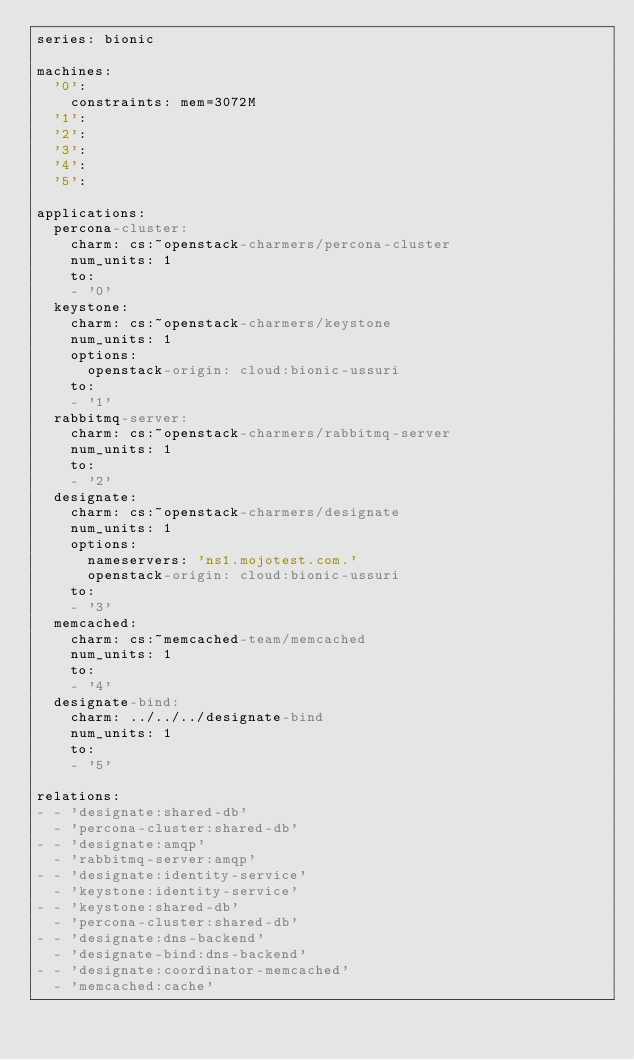Convert code to text. <code><loc_0><loc_0><loc_500><loc_500><_YAML_>series: bionic

machines:
  '0':
    constraints: mem=3072M
  '1':
  '2':
  '3':
  '4':
  '5':

applications:
  percona-cluster:
    charm: cs:~openstack-charmers/percona-cluster
    num_units: 1
    to:
    - '0'
  keystone:
    charm: cs:~openstack-charmers/keystone
    num_units: 1
    options:
      openstack-origin: cloud:bionic-ussuri
    to:
    - '1'
  rabbitmq-server:
    charm: cs:~openstack-charmers/rabbitmq-server
    num_units: 1
    to:
    - '2'
  designate:
    charm: cs:~openstack-charmers/designate
    num_units: 1
    options:
      nameservers: 'ns1.mojotest.com.'
      openstack-origin: cloud:bionic-ussuri
    to:
    - '3'
  memcached:
    charm: cs:~memcached-team/memcached
    num_units: 1
    to:
    - '4'
  designate-bind:
    charm: ../../../designate-bind
    num_units: 1
    to:
    - '5'

relations:
- - 'designate:shared-db'
  - 'percona-cluster:shared-db'
- - 'designate:amqp'
  - 'rabbitmq-server:amqp'
- - 'designate:identity-service'
  - 'keystone:identity-service'
- - 'keystone:shared-db'
  - 'percona-cluster:shared-db'
- - 'designate:dns-backend'
  - 'designate-bind:dns-backend'
- - 'designate:coordinator-memcached'
  - 'memcached:cache'
</code> 